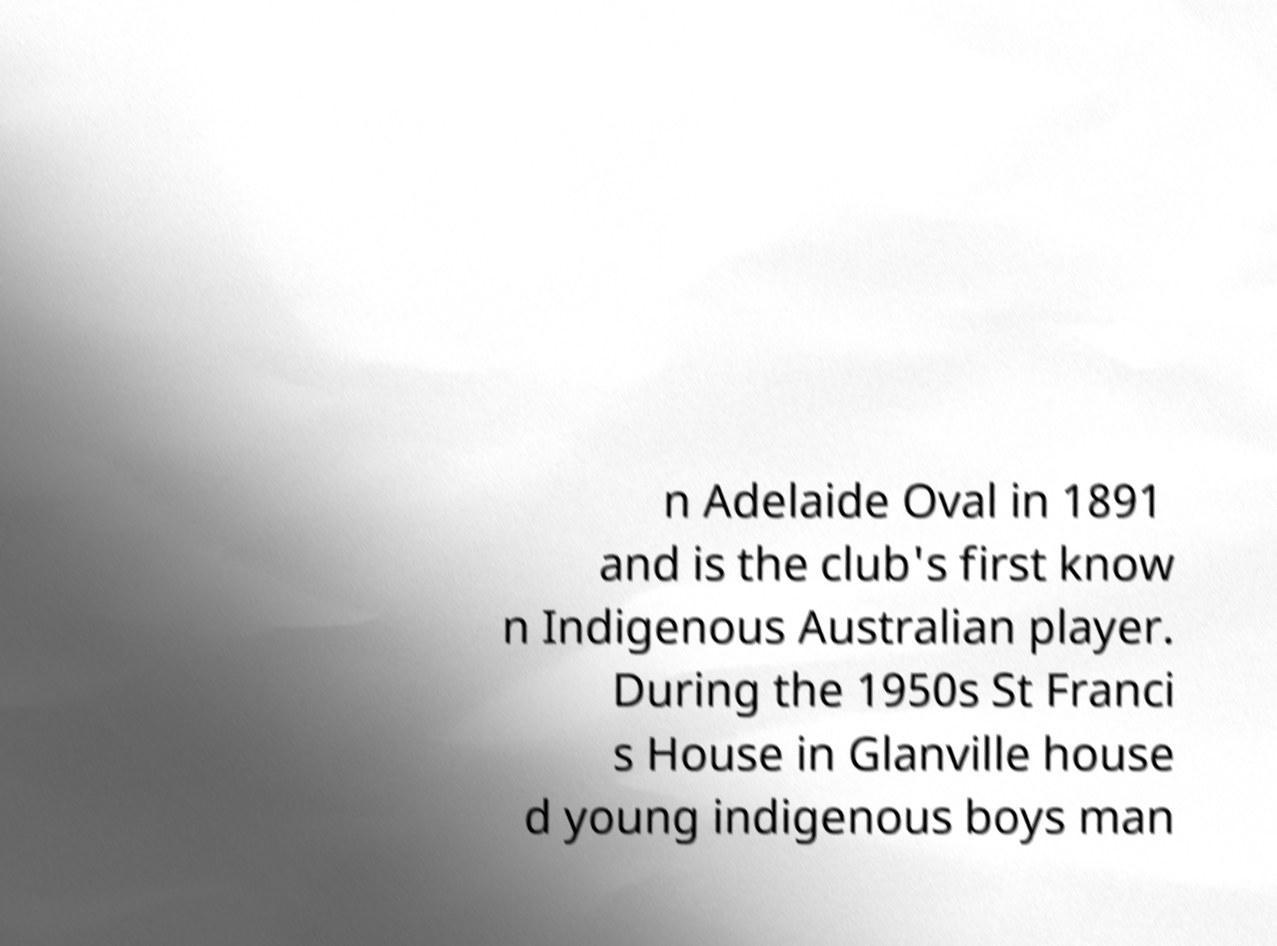Could you extract and type out the text from this image? n Adelaide Oval in 1891 and is the club's first know n Indigenous Australian player. During the 1950s St Franci s House in Glanville house d young indigenous boys man 